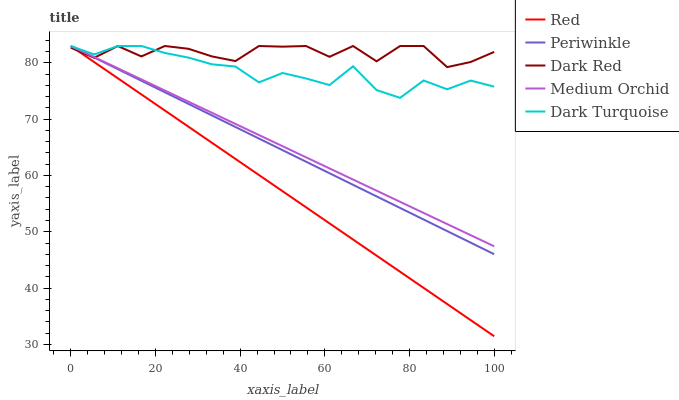Does Red have the minimum area under the curve?
Answer yes or no. Yes. Does Dark Red have the maximum area under the curve?
Answer yes or no. Yes. Does Medium Orchid have the minimum area under the curve?
Answer yes or no. No. Does Medium Orchid have the maximum area under the curve?
Answer yes or no. No. Is Periwinkle the smoothest?
Answer yes or no. Yes. Is Dark Red the roughest?
Answer yes or no. Yes. Is Medium Orchid the smoothest?
Answer yes or no. No. Is Medium Orchid the roughest?
Answer yes or no. No. Does Red have the lowest value?
Answer yes or no. Yes. Does Medium Orchid have the lowest value?
Answer yes or no. No. Does Dark Turquoise have the highest value?
Answer yes or no. Yes. Does Dark Turquoise intersect Medium Orchid?
Answer yes or no. Yes. Is Dark Turquoise less than Medium Orchid?
Answer yes or no. No. Is Dark Turquoise greater than Medium Orchid?
Answer yes or no. No. 